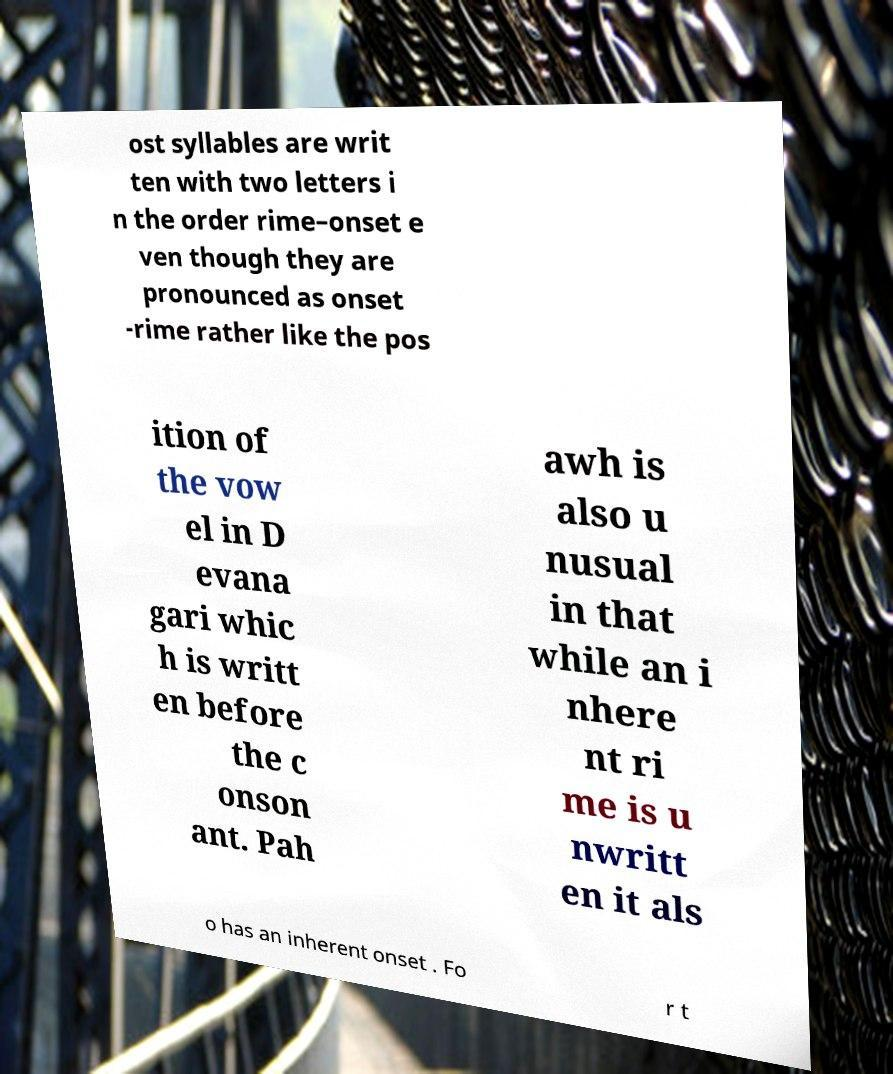Could you extract and type out the text from this image? ost syllables are writ ten with two letters i n the order rime–onset e ven though they are pronounced as onset -rime rather like the pos ition of the vow el in D evana gari whic h is writt en before the c onson ant. Pah awh is also u nusual in that while an i nhere nt ri me is u nwritt en it als o has an inherent onset . Fo r t 